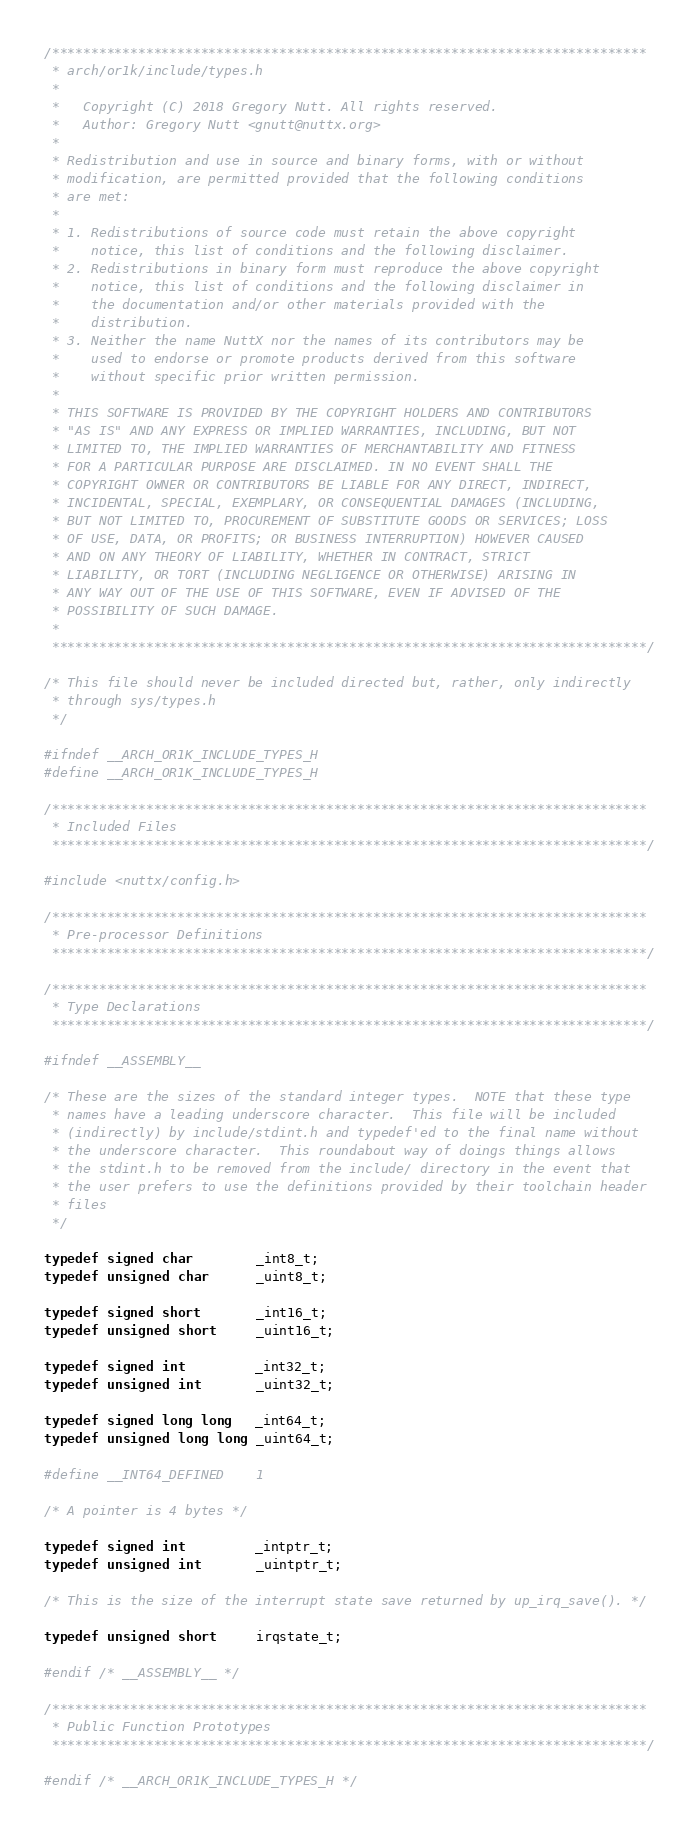Convert code to text. <code><loc_0><loc_0><loc_500><loc_500><_C_>/****************************************************************************
 * arch/or1k/include/types.h
 *
 *   Copyright (C) 2018 Gregory Nutt. All rights reserved.
 *   Author: Gregory Nutt <gnutt@nuttx.org>
 *
 * Redistribution and use in source and binary forms, with or without
 * modification, are permitted provided that the following conditions
 * are met:
 *
 * 1. Redistributions of source code must retain the above copyright
 *    notice, this list of conditions and the following disclaimer.
 * 2. Redistributions in binary form must reproduce the above copyright
 *    notice, this list of conditions and the following disclaimer in
 *    the documentation and/or other materials provided with the
 *    distribution.
 * 3. Neither the name NuttX nor the names of its contributors may be
 *    used to endorse or promote products derived from this software
 *    without specific prior written permission.
 *
 * THIS SOFTWARE IS PROVIDED BY THE COPYRIGHT HOLDERS AND CONTRIBUTORS
 * "AS IS" AND ANY EXPRESS OR IMPLIED WARRANTIES, INCLUDING, BUT NOT
 * LIMITED TO, THE IMPLIED WARRANTIES OF MERCHANTABILITY AND FITNESS
 * FOR A PARTICULAR PURPOSE ARE DISCLAIMED. IN NO EVENT SHALL THE
 * COPYRIGHT OWNER OR CONTRIBUTORS BE LIABLE FOR ANY DIRECT, INDIRECT,
 * INCIDENTAL, SPECIAL, EXEMPLARY, OR CONSEQUENTIAL DAMAGES (INCLUDING,
 * BUT NOT LIMITED TO, PROCUREMENT OF SUBSTITUTE GOODS OR SERVICES; LOSS
 * OF USE, DATA, OR PROFITS; OR BUSINESS INTERRUPTION) HOWEVER CAUSED
 * AND ON ANY THEORY OF LIABILITY, WHETHER IN CONTRACT, STRICT
 * LIABILITY, OR TORT (INCLUDING NEGLIGENCE OR OTHERWISE) ARISING IN
 * ANY WAY OUT OF THE USE OF THIS SOFTWARE, EVEN IF ADVISED OF THE
 * POSSIBILITY OF SUCH DAMAGE.
 *
 ****************************************************************************/

/* This file should never be included directed but, rather, only indirectly
 * through sys/types.h
 */

#ifndef __ARCH_OR1K_INCLUDE_TYPES_H
#define __ARCH_OR1K_INCLUDE_TYPES_H

/****************************************************************************
 * Included Files
 ****************************************************************************/

#include <nuttx/config.h>

/****************************************************************************
 * Pre-processor Definitions
 ****************************************************************************/

/****************************************************************************
 * Type Declarations
 ****************************************************************************/

#ifndef __ASSEMBLY__

/* These are the sizes of the standard integer types.  NOTE that these type
 * names have a leading underscore character.  This file will be included
 * (indirectly) by include/stdint.h and typedef'ed to the final name without
 * the underscore character.  This roundabout way of doings things allows
 * the stdint.h to be removed from the include/ directory in the event that
 * the user prefers to use the definitions provided by their toolchain header
 * files
 */

typedef signed char        _int8_t;
typedef unsigned char      _uint8_t;

typedef signed short       _int16_t;
typedef unsigned short     _uint16_t;

typedef signed int         _int32_t;
typedef unsigned int       _uint32_t;

typedef signed long long   _int64_t;
typedef unsigned long long _uint64_t;

#define __INT64_DEFINED    1

/* A pointer is 4 bytes */

typedef signed int         _intptr_t;
typedef unsigned int       _uintptr_t;

/* This is the size of the interrupt state save returned by up_irq_save(). */

typedef unsigned short     irqstate_t;

#endif /* __ASSEMBLY__ */

/****************************************************************************
 * Public Function Prototypes
 ****************************************************************************/

#endif /* __ARCH_OR1K_INCLUDE_TYPES_H */
</code> 